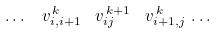<formula> <loc_0><loc_0><loc_500><loc_500>\dots \, \ v _ { i , i + 1 } ^ { \, k } \, \ v _ { i j } ^ { \, k + 1 } \, \ v _ { i + 1 , j } ^ { \, k } \, \dots</formula> 